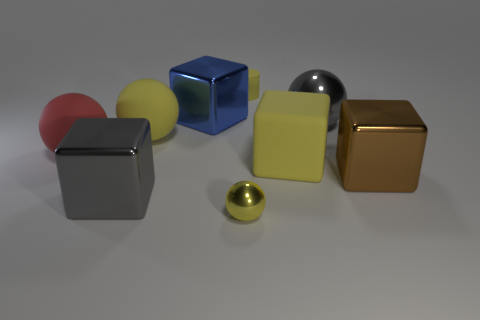Can you tell me more about the lighting in this image? Where is it coming from? The shadows and highlights suggest that the lighting in the image is coming from above, slightly to the left. This overhead lighting casts soft shadows and gives the scene a calm ambiance. 